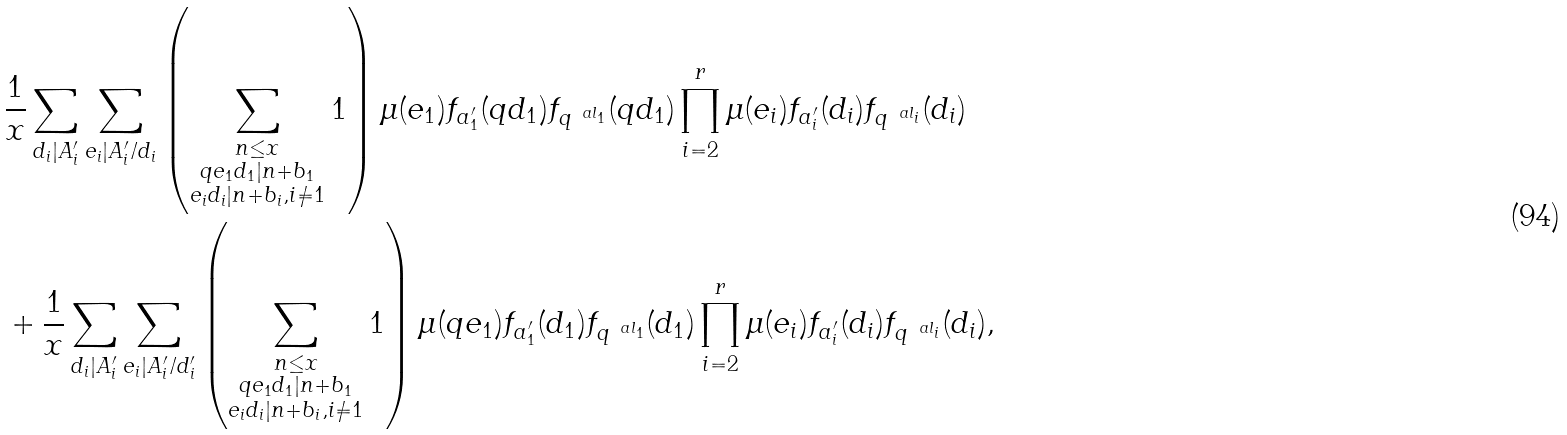Convert formula to latex. <formula><loc_0><loc_0><loc_500><loc_500>& \frac { 1 } { x } \sum _ { d _ { i } | A _ { i } ^ { \prime } } \sum _ { e _ { i } | A _ { i } ^ { \prime } / d _ { i } } \left ( \sum _ { \substack { n \leq x \\ q e _ { 1 } d _ { 1 } | n + b _ { 1 } \\ e _ { i } d _ { i } | n + b _ { i } , i \neq 1 } } 1 \right ) \mu ( e _ { 1 } ) f _ { a _ { 1 } ^ { \prime } } ( q d _ { 1 } ) f _ { q ^ { \ a l _ { 1 } } } ( q d _ { 1 } ) \prod _ { i = 2 } ^ { r } \mu ( e _ { i } ) f _ { a _ { i } ^ { \prime } } ( d _ { i } ) f _ { q ^ { \ a l _ { i } } } ( d _ { i } ) \\ & + \frac { 1 } { x } \sum _ { d _ { i } | A _ { i } ^ { \prime } } \sum _ { e _ { i } | A _ { i } ^ { \prime } / d _ { i } ^ { \prime } } \left ( \sum _ { \substack { n \leq x \\ q e _ { 1 } d _ { 1 } | n + b _ { 1 } \\ e _ { i } d _ { i } | n + b _ { i } , i \neq 1 } } 1 \right ) \mu ( q e _ { 1 } ) f _ { a _ { 1 } ^ { \prime } } ( d _ { 1 } ) f _ { q ^ { \ a l _ { 1 } } } ( d _ { 1 } ) \prod _ { i = 2 } ^ { r } \mu ( e _ { i } ) f _ { a _ { i } ^ { \prime } } ( d _ { i } ) f _ { q ^ { \ a l _ { i } } } ( d _ { i } ) ,</formula> 